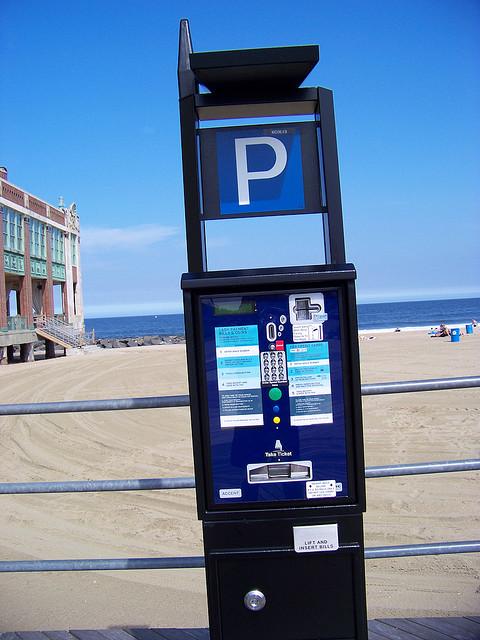Is that an ATM machine or a vending machine?
Be succinct. Atm. What does the P stand for?
Concise answer only. Parking. Was this picture taken on a mountain?
Concise answer only. No. 